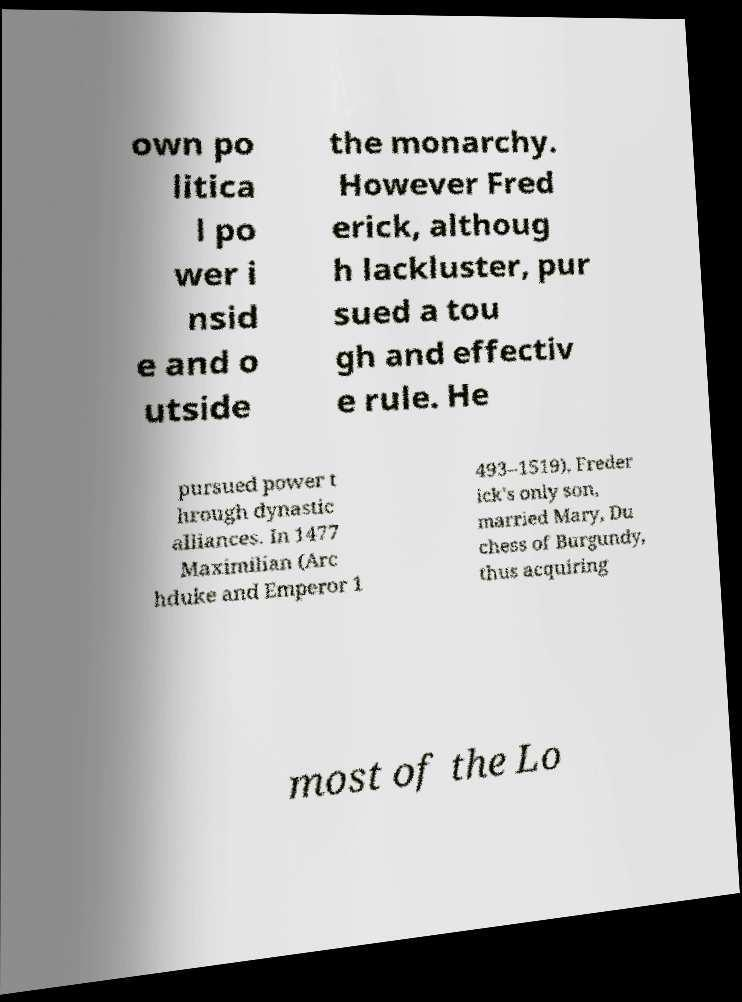Please read and relay the text visible in this image. What does it say? own po litica l po wer i nsid e and o utside the monarchy. However Fred erick, althoug h lackluster, pur sued a tou gh and effectiv e rule. He pursued power t hrough dynastic alliances. In 1477 Maximilian (Arc hduke and Emperor 1 493–1519), Freder ick's only son, married Mary, Du chess of Burgundy, thus acquiring most of the Lo 